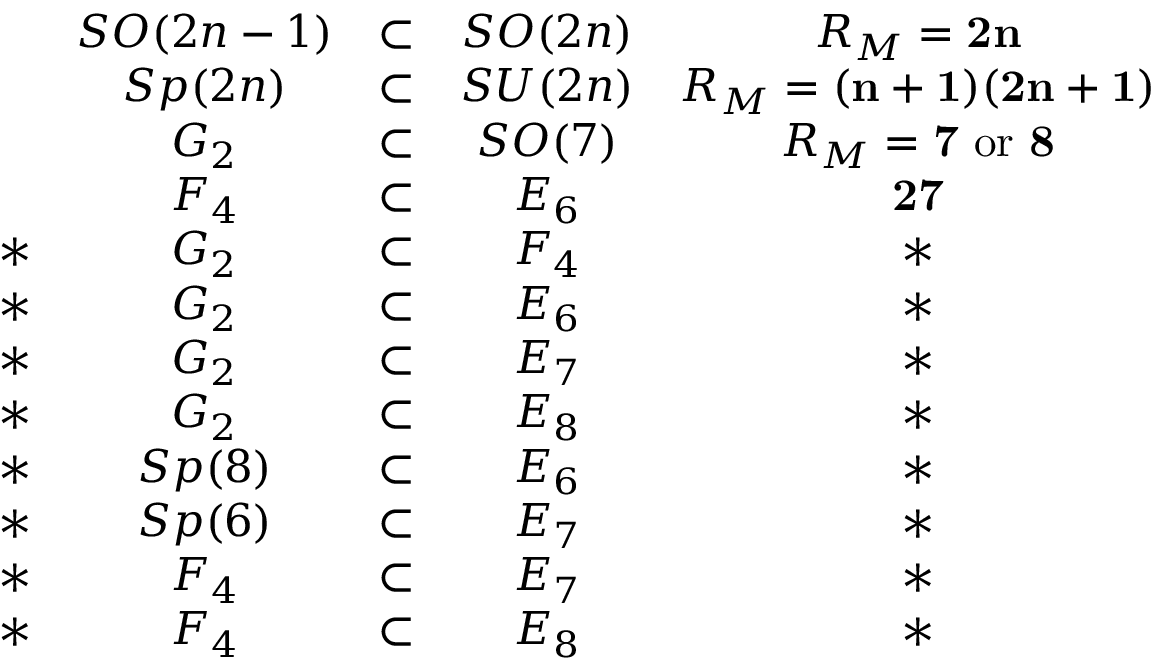<formula> <loc_0><loc_0><loc_500><loc_500>\begin{array} { c c c c c & { S O ( 2 n - 1 ) } & { \subset } & { S O ( 2 n ) } & { { R _ { M } = { 2 n } } } & { S p ( 2 n ) } & { \subset } & { S U ( 2 n ) } & { { R _ { M } = { ( n + 1 ) ( 2 n + 1 ) } } } & { { G _ { 2 } } } & { \subset } & { S O ( 7 ) } & { { R _ { M } = { 7 } \ o r \ { 8 } } } & { { F _ { 4 } } } & { \subset } & { { E _ { 6 } } } & { 2 7 } \\ { \ast } & { { G _ { 2 } } } & { \subset } & { { F _ { 4 } } } & { \ast } \\ { \ast } & { { G _ { 2 } } } & { \subset } & { { E _ { 6 } } } & { \ast } \\ { \ast } & { { G _ { 2 } } } & { \subset } & { { E _ { 7 } } } & { \ast } \\ { \ast } & { { G _ { 2 } } } & { \subset } & { { E _ { 8 } } } & { \ast } \\ { \ast } & { S p ( 8 ) } & { \subset } & { { E _ { 6 } } } & { \ast } \\ { \ast } & { S p ( 6 ) } & { \subset } & { { E _ { 7 } } } & { \ast } \\ { \ast } & { { F _ { 4 } } } & { \subset } & { { E _ { 7 } } } & { \ast } \\ { \ast } & { { F _ { 4 } } } & { \subset } & { { E _ { 8 } } } & { \ast } \end{array}</formula> 